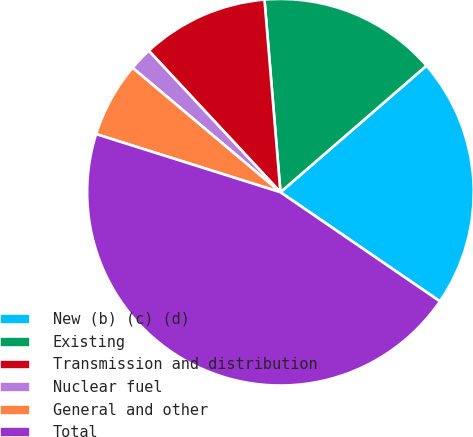Convert chart. <chart><loc_0><loc_0><loc_500><loc_500><pie_chart><fcel>New (b) (c) (d)<fcel>Existing<fcel>Transmission and distribution<fcel>Nuclear fuel<fcel>General and other<fcel>Total<nl><fcel>20.91%<fcel>14.95%<fcel>10.61%<fcel>1.94%<fcel>6.27%<fcel>45.31%<nl></chart> 